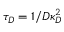Convert formula to latex. <formula><loc_0><loc_0><loc_500><loc_500>\tau _ { D } = 1 / D \kappa _ { D } ^ { 2 }</formula> 